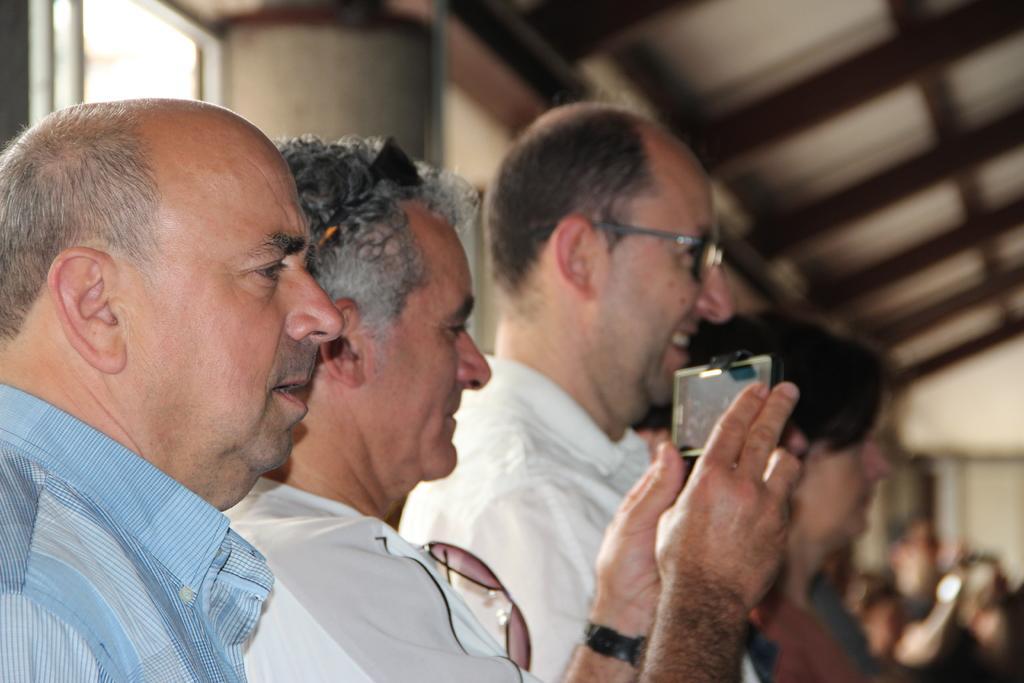How would you summarize this image in a sentence or two? In this image we can see a few people, one of them is holding a cell phone, also we can see the wall, window, and the roof, the background is blurred. 